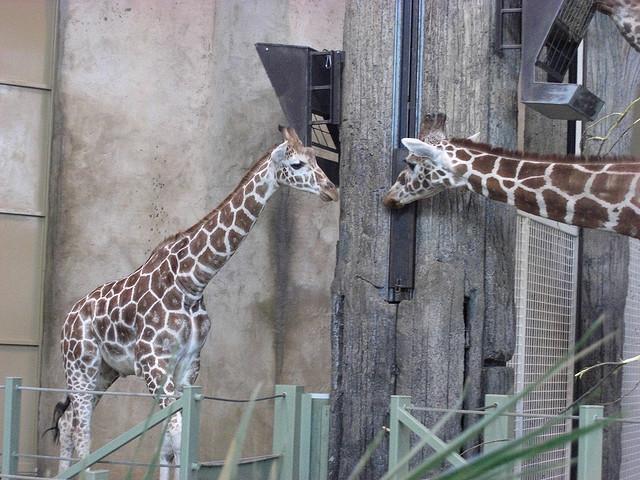How many animals are there?
Write a very short answer. 2. What color is the fence?
Short answer required. Green. Is the giraffe's ears forward or backwards?
Keep it brief. Forward. Are all of the giraffe's bodies fully visible in the picture?
Keep it brief. No. What animal is this?
Short answer required. Giraffe. 